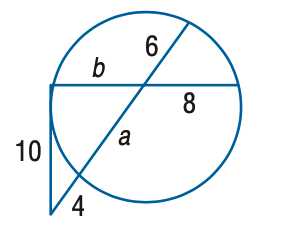Question: Find the variable of b to the nearest tenth. Assume that segments that appear to be tangent are tangent.
Choices:
A. 11.3
B. 11.8
C. 12.3
D. 12.8
Answer with the letter. Answer: A 